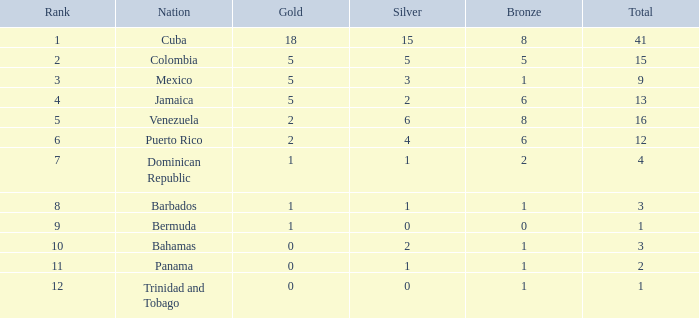Which total is the smallest one with a rank less than 2 and a silver less than 15? None. 